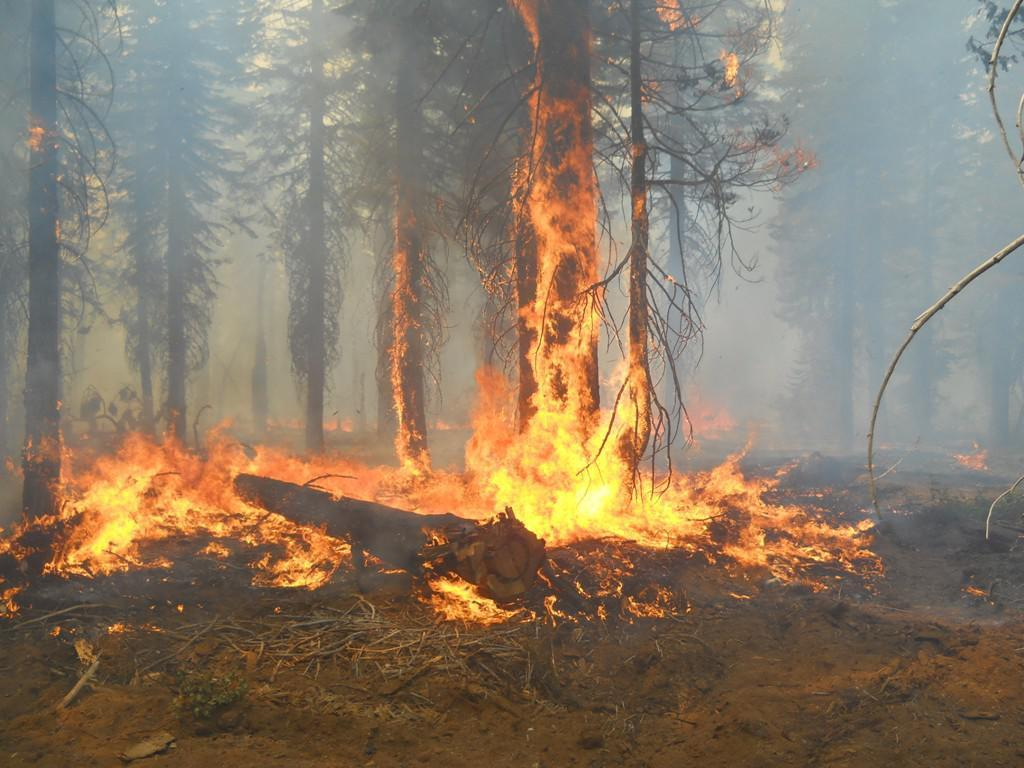What is the primary element in the image? There is fire in the image. What type of natural environment is depicted in the image? There are trees in the image, suggesting a forest or wooded area. What type of brush is being used to paint the trees in the image? There is no brush or painting activity present in the image; it depicts actual trees and fire. 